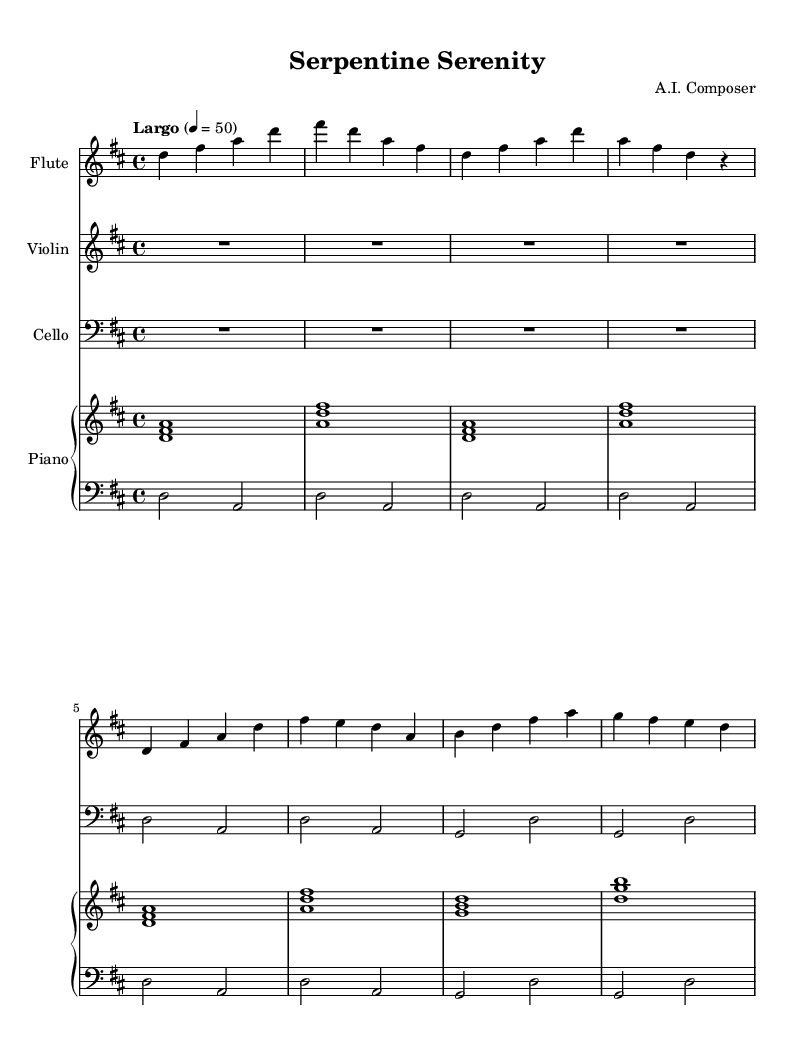What is the key signature of this music? The key signature is indicated at the beginning of the staff, showing two sharps, which correspond to F sharp and C sharp. This indicates that the piece is in D major.
Answer: D major What is the time signature of this piece? The time signature is found at the beginning of the score, indicated by the fraction 4/4. This means there are four beats in each measure and the quarter note receives one beat.
Answer: 4/4 What is the tempo marking for this composition? The tempo marking is provided within the score; it specifies "Largo," indicating a slow tempo, along with the metronome marking of 50 beats per minute.
Answer: Largo How many measures are in the flute part? By counting the distinct measures in the flute section, we find there are a total of four measures as represented by the notation.
Answer: 4 What instruments are part of this arrangement? The arrangement includes flute, violin, cello, and piano. Each has its own staff indicated in the score.
Answer: Flute, violin, cello, piano What is the resting measure in the violin part? The resting measure is represented by the notation R1*4, indicating a full measure of rest before the violin plays.
Answer: One full measure of rest In which octave is the cello melody primarily written? The cello melody notes start in a pitch range identified by the use of the bass clef, indicating that it is written primarily in the lower octave suitable for the cello.
Answer: Bass clef (lower octave) 